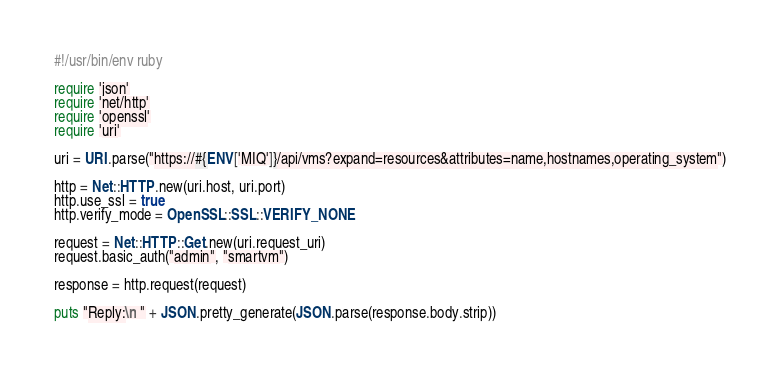Convert code to text. <code><loc_0><loc_0><loc_500><loc_500><_Ruby_>#!/usr/bin/env ruby

require 'json'
require 'net/http'
require 'openssl'
require 'uri'

uri = URI.parse("https://#{ENV['MIQ']}/api/vms?expand=resources&attributes=name,hostnames,operating_system")

http = Net::HTTP.new(uri.host, uri.port)
http.use_ssl = true
http.verify_mode = OpenSSL::SSL::VERIFY_NONE

request = Net::HTTP::Get.new(uri.request_uri)
request.basic_auth("admin", "smartvm")

response = http.request(request)

puts "Reply:\n " + JSON.pretty_generate(JSON.parse(response.body.strip))

</code> 